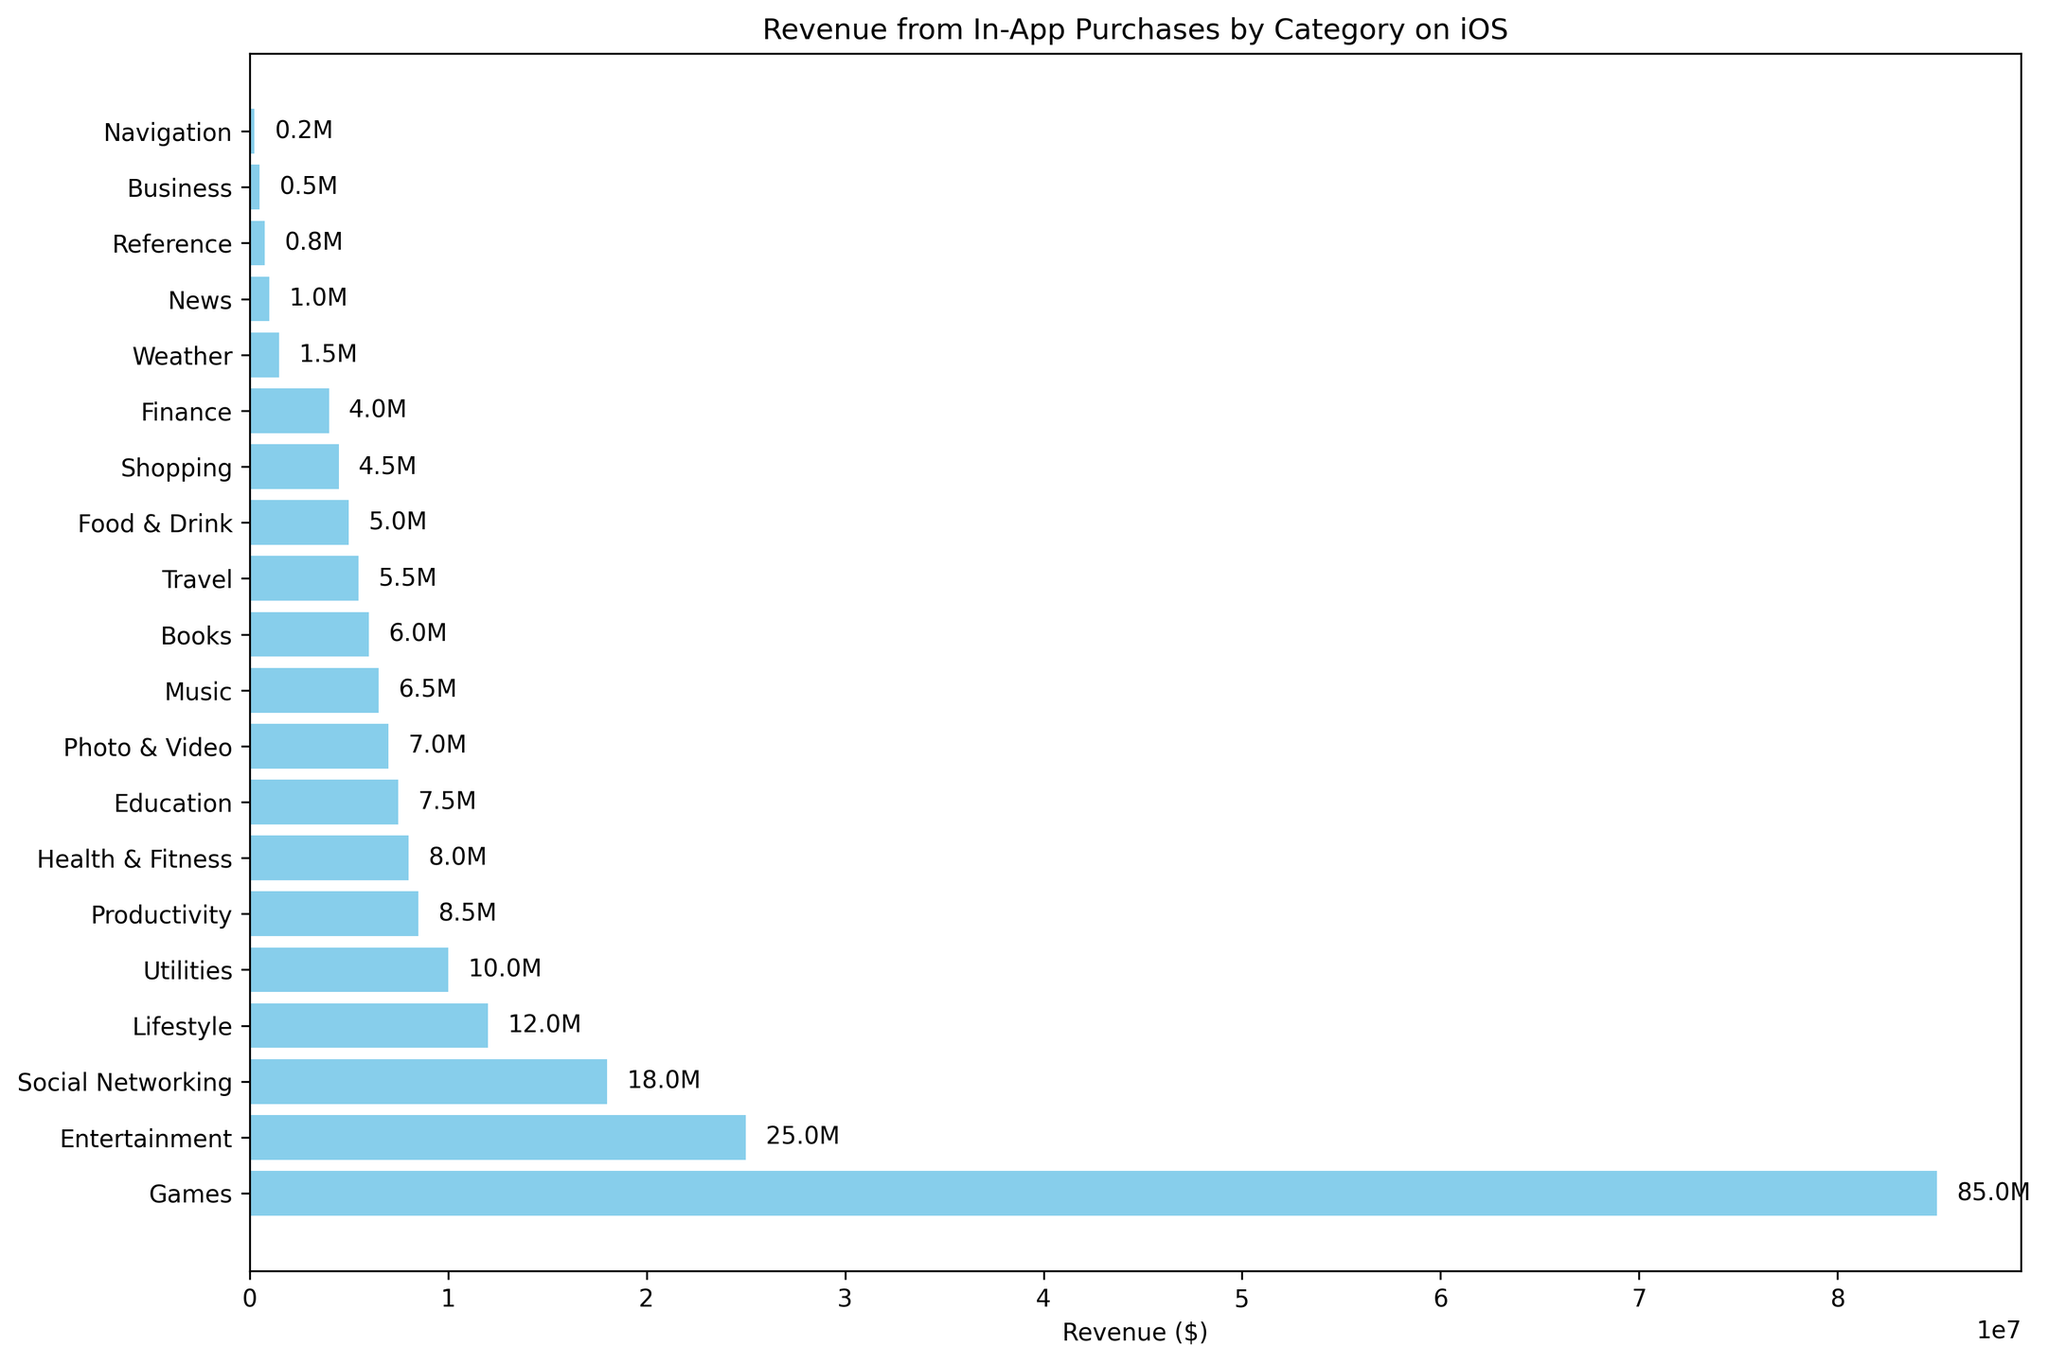What's the category with the highest revenue? The category with the highest revenue has the longest bar in the plot.
Answer: Games Which category generates more revenue, Social Networking or Food & Drink? By comparing the lengths of the bars for Social Networking and Food & Drink, Social Networking has a longer bar, indicating higher revenue.
Answer: Social Networking What is the total revenue generated by Entertainment and Music categories combined? The revenue for Entertainment is $25M and for Music is $6.5M. Adding these together: $25M + $6.5M = $31.5M.
Answer: $31.5M Which category has the shortest bar in the chart, indicating the lowest revenue? The shortest bar in the plot signifies the category with the lowest revenue.
Answer: Navigation How much more revenue does the Games category generate compared to the Utilities category? The revenue for Games is $85M and for Utilities it is $10M. The difference is $85M - $10M = $75M.
Answer: $75M Which categories generate between $5M and $10M in revenue? By examining the bars, the categories with revenues between $5M and $10M are Health & Fitness ($8M), Education ($7.5M), Photo & Video ($7M), Music ($6.5M), Books ($6M), Travel ($5.5M), and Food & Drink ($5M).
Answer: Health & Fitness, Education, Photo & Video, Music, Books, Travel, Food & Drink What's the combined revenue of the top three categories? The top three categories are Games ($85M), Entertainment ($25M), and Social Networking ($18M). The total revenue is $85M + $25M + $18M = $128M.
Answer: $128M Which category generates less revenue, Weather or Business? By comparing the lengths of the bars for Weather and Business, Business has a shorter bar, indicating lower revenue.
Answer: Business 